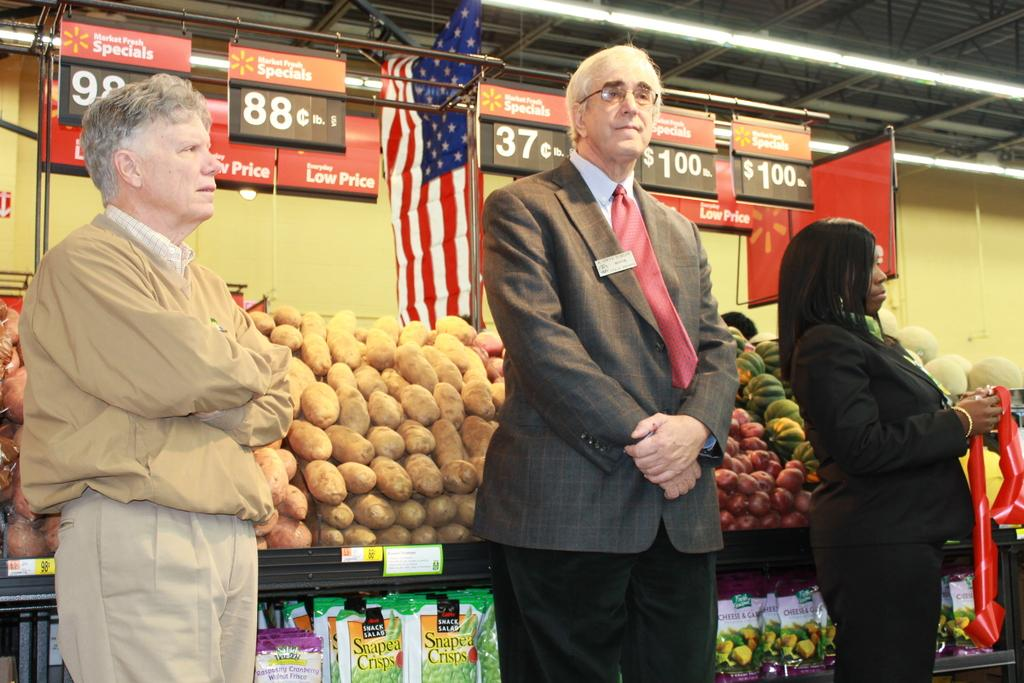<image>
Write a terse but informative summary of the picture. Three people standing by a vegetable stand in the fresh market specials area. 